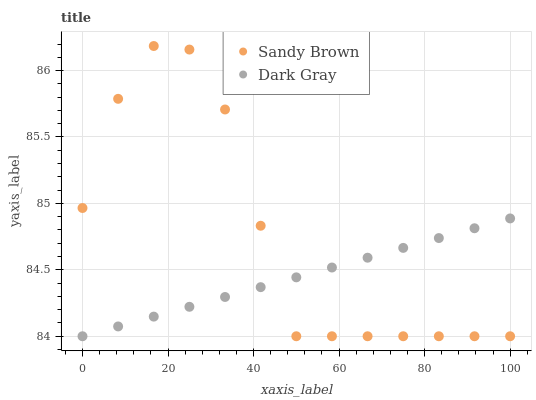Does Dark Gray have the minimum area under the curve?
Answer yes or no. Yes. Does Sandy Brown have the maximum area under the curve?
Answer yes or no. Yes. Does Sandy Brown have the minimum area under the curve?
Answer yes or no. No. Is Dark Gray the smoothest?
Answer yes or no. Yes. Is Sandy Brown the roughest?
Answer yes or no. Yes. Is Sandy Brown the smoothest?
Answer yes or no. No. Does Dark Gray have the lowest value?
Answer yes or no. Yes. Does Sandy Brown have the highest value?
Answer yes or no. Yes. Does Sandy Brown intersect Dark Gray?
Answer yes or no. Yes. Is Sandy Brown less than Dark Gray?
Answer yes or no. No. Is Sandy Brown greater than Dark Gray?
Answer yes or no. No. 